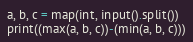<code> <loc_0><loc_0><loc_500><loc_500><_Python_>a, b, c = map(int, input().split())
print((max(a, b, c))-(min(a, b, c)))
</code> 